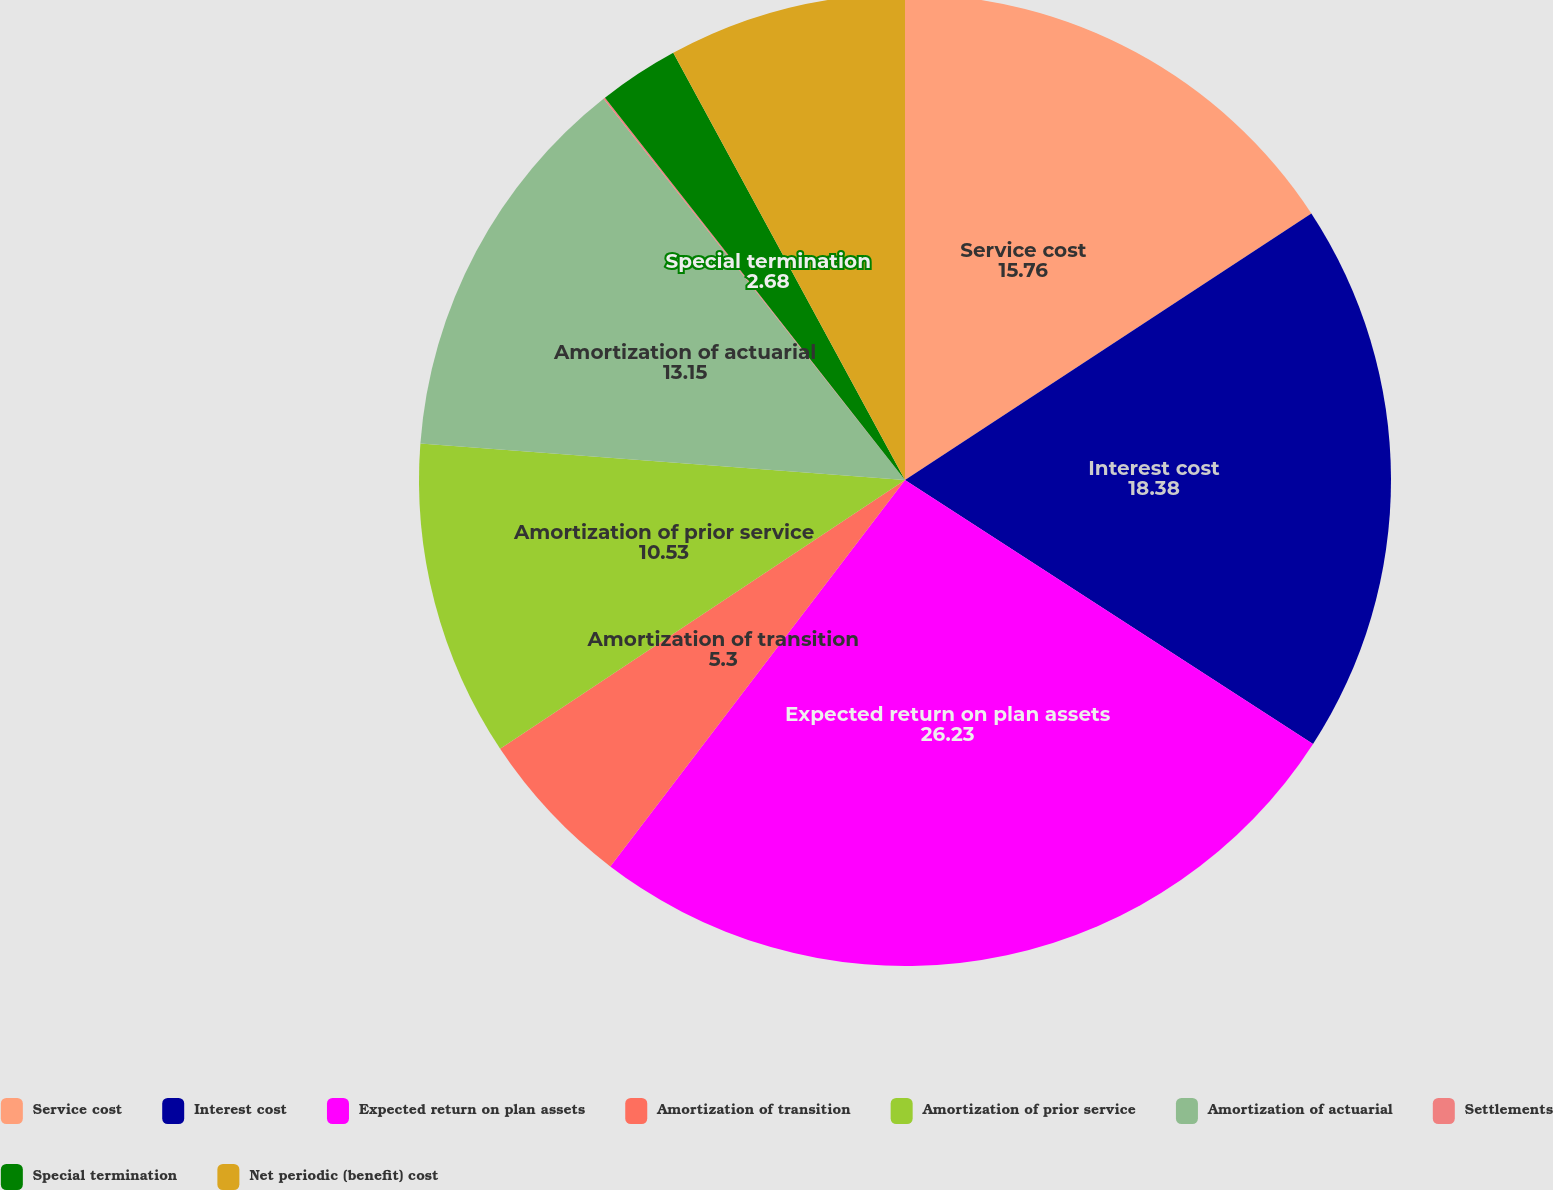<chart> <loc_0><loc_0><loc_500><loc_500><pie_chart><fcel>Service cost<fcel>Interest cost<fcel>Expected return on plan assets<fcel>Amortization of transition<fcel>Amortization of prior service<fcel>Amortization of actuarial<fcel>Settlements<fcel>Special termination<fcel>Net periodic (benefit) cost<nl><fcel>15.76%<fcel>18.38%<fcel>26.23%<fcel>5.3%<fcel>10.53%<fcel>13.15%<fcel>0.06%<fcel>2.68%<fcel>7.91%<nl></chart> 